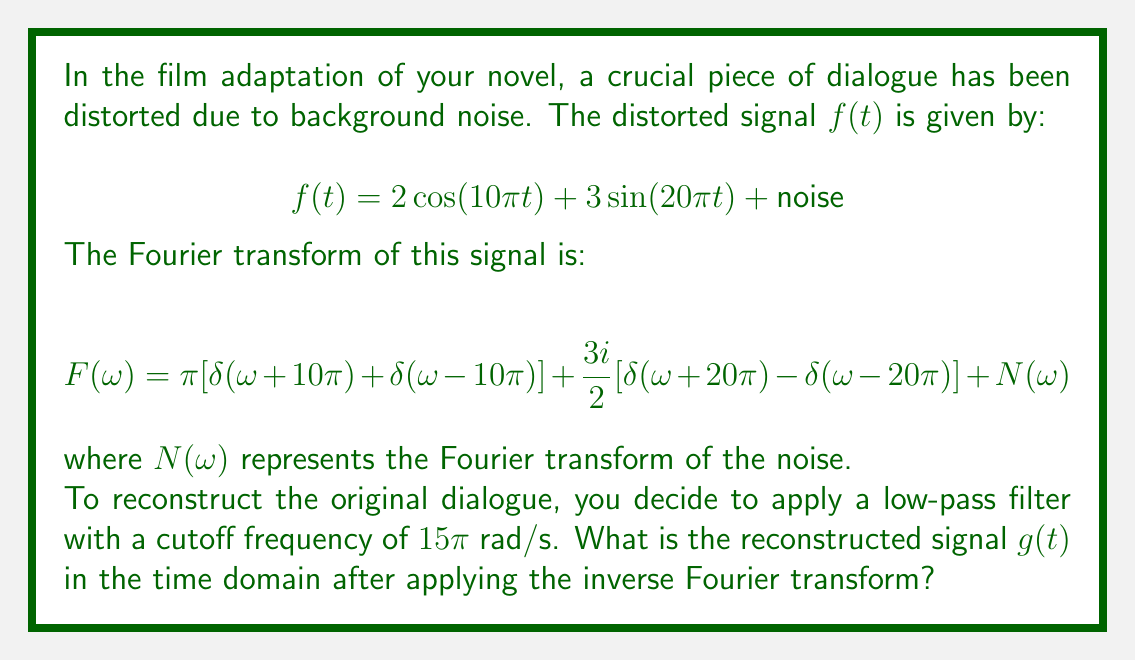Can you answer this question? Let's approach this step-by-step:

1) The low-pass filter will remove all frequencies above $15\pi$ rad/s. This means it will keep the $2\cos(10\pi t)$ term but remove the $3\sin(20\pi t)$ term and most of the noise.

2) After applying the filter, our frequency domain signal becomes:

   $$G(\omega) = \pi[\delta(\omega+10\pi) + \delta(\omega-10\pi)]$$

3) To find $g(t)$, we need to apply the inverse Fourier transform to $G(\omega)$. The inverse Fourier transform is given by:

   $$g(t) = \frac{1}{2\pi}\int_{-\infty}^{\infty} G(\omega)e^{i\omega t} d\omega$$

4) Substituting our $G(\omega)$:

   $$g(t) = \frac{1}{2\pi}\int_{-\infty}^{\infty} \pi[\delta(\omega+10\pi) + \delta(\omega-10\pi)]e^{i\omega t} d\omega$$

5) Using the sifting property of the delta function:

   $$g(t) = \frac{1}{2}[e^{-i10\pi t} + e^{i10\pi t}]$$

6) This can be simplified using Euler's formula:

   $$g(t) = \frac{1}{2}[(\cos(-10\pi t) + i\sin(-10\pi t)) + (\cos(10\pi t) + i\sin(10\pi t))]$$
   $$g(t) = \frac{1}{2}[(\cos(10\pi t) - i\sin(10\pi t)) + (\cos(10\pi t) + i\sin(10\pi t))]$$
   $$g(t) = \cos(10\pi t)$$

7) To match the original amplitude:

   $$g(t) = 2\cos(10\pi t)$$
Answer: $g(t) = 2\cos(10\pi t)$ 